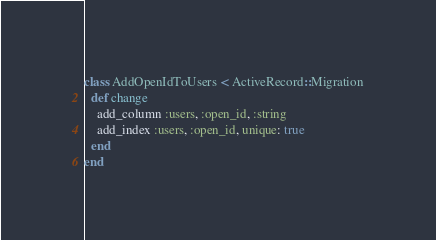<code> <loc_0><loc_0><loc_500><loc_500><_Ruby_>class AddOpenIdToUsers < ActiveRecord::Migration
  def change
    add_column :users, :open_id, :string
    add_index :users, :open_id, unique: true
  end
end
</code> 